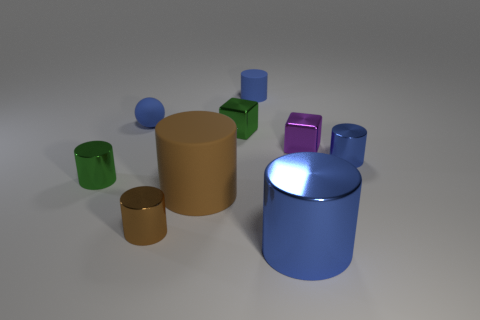Subtract all blue metal cylinders. How many cylinders are left? 4 Subtract 1 balls. How many balls are left? 0 Subtract all brown cylinders. How many cylinders are left? 4 Subtract all balls. How many objects are left? 8 Subtract all yellow cylinders. How many yellow spheres are left? 0 Subtract 0 purple cylinders. How many objects are left? 9 Subtract all red cylinders. Subtract all gray balls. How many cylinders are left? 6 Subtract all tiny shiny objects. Subtract all big yellow matte objects. How many objects are left? 4 Add 4 tiny green shiny cylinders. How many tiny green shiny cylinders are left? 5 Add 9 green balls. How many green balls exist? 9 